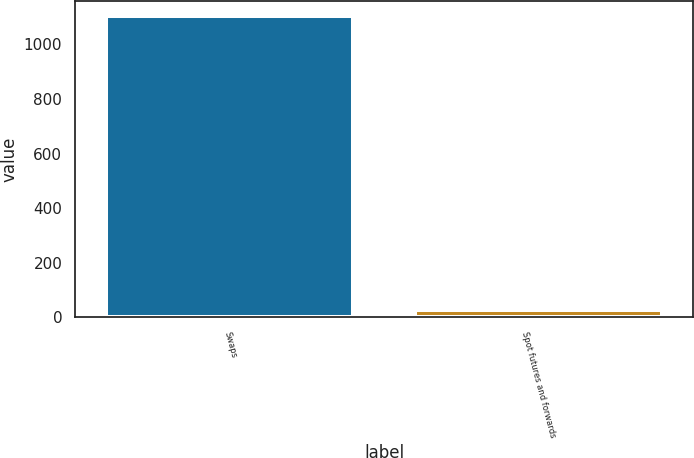Convert chart. <chart><loc_0><loc_0><loc_500><loc_500><bar_chart><fcel>Swaps<fcel>Spot futures and forwards<nl><fcel>1105<fcel>25.6<nl></chart> 